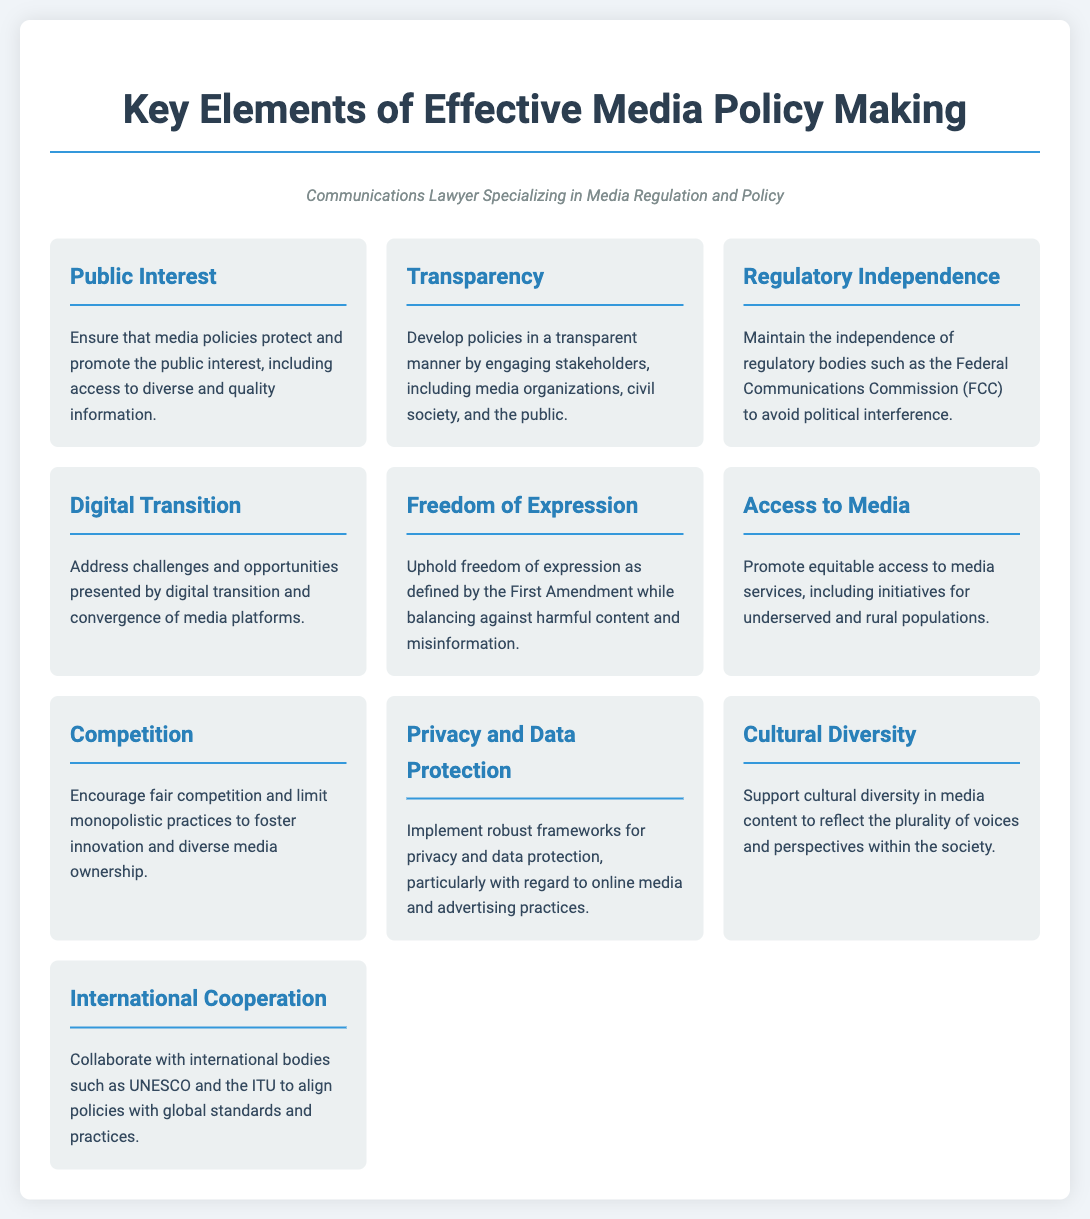What is the first element listed? The first element in the list is "Public Interest," which is the title of the first box in the infographic.
Answer: Public Interest How many elements are there in total? The document lists a total of ten key elements of effective media policy making, as inferred from the number of boxes.
Answer: 10 What element addresses challenges related to digital media? The element that addresses challenges related to digital media is titled "Digital Transition."
Answer: Digital Transition Which element emphasizes the importance of privacy? The element that emphasizes the importance of privacy is titled "Privacy and Data Protection."
Answer: Privacy and Data Protection What is one way to promote equitable access to media? The document states that initiatives for underserved and rural populations can promote equitable access to media.
Answer: Initiatives for underserved and rural populations Which key element supports international collaboration? The element that supports international collaboration is titled "International Cooperation."
Answer: International Cooperation What does the element on "Freedom of Expression" balance against? The element on "Freedom of Expression" balances freedom with harmful content and misinformation.
Answer: Harmful content and misinformation What is the significance of "Regulatory Independence"? The significance of "Regulatory Independence" is to avoid political interference in regulatory bodies.
Answer: Avoid political interference What concept is addressed for fostering innovation in media? The concept addressed for fostering innovation in media is "Competition," which encourages fair practices.
Answer: Competition What type of diversity is emphasized in media policy? The document emphasizes "Cultural Diversity," which reflects plurality of voices in society.
Answer: Cultural Diversity 